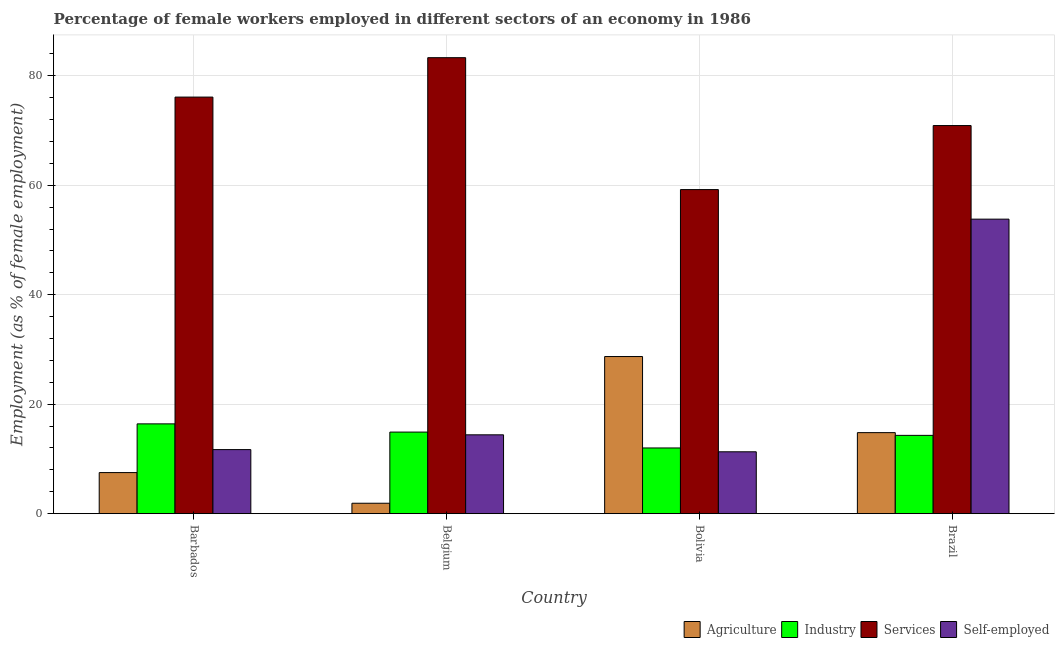Are the number of bars per tick equal to the number of legend labels?
Your answer should be compact. Yes. Are the number of bars on each tick of the X-axis equal?
Your answer should be very brief. Yes. What is the label of the 1st group of bars from the left?
Your answer should be compact. Barbados. What is the percentage of female workers in industry in Barbados?
Give a very brief answer. 16.4. Across all countries, what is the maximum percentage of self employed female workers?
Your answer should be compact. 53.8. Across all countries, what is the minimum percentage of female workers in services?
Make the answer very short. 59.2. In which country was the percentage of female workers in industry maximum?
Offer a very short reply. Barbados. What is the total percentage of female workers in services in the graph?
Keep it short and to the point. 289.5. What is the difference between the percentage of female workers in services in Bolivia and that in Brazil?
Give a very brief answer. -11.7. What is the difference between the percentage of female workers in agriculture in Bolivia and the percentage of female workers in industry in Barbados?
Provide a succinct answer. 12.3. What is the average percentage of self employed female workers per country?
Make the answer very short. 22.8. What is the difference between the percentage of self employed female workers and percentage of female workers in industry in Bolivia?
Ensure brevity in your answer.  -0.7. What is the ratio of the percentage of female workers in services in Bolivia to that in Brazil?
Your response must be concise. 0.83. Is the difference between the percentage of female workers in services in Belgium and Brazil greater than the difference between the percentage of self employed female workers in Belgium and Brazil?
Your answer should be very brief. Yes. What is the difference between the highest and the second highest percentage of female workers in industry?
Your answer should be compact. 1.5. What is the difference between the highest and the lowest percentage of female workers in agriculture?
Your answer should be very brief. 26.8. Is it the case that in every country, the sum of the percentage of female workers in services and percentage of female workers in agriculture is greater than the sum of percentage of female workers in industry and percentage of self employed female workers?
Give a very brief answer. Yes. What does the 2nd bar from the left in Brazil represents?
Provide a short and direct response. Industry. What does the 1st bar from the right in Bolivia represents?
Provide a short and direct response. Self-employed. Is it the case that in every country, the sum of the percentage of female workers in agriculture and percentage of female workers in industry is greater than the percentage of female workers in services?
Your answer should be compact. No. How many bars are there?
Provide a succinct answer. 16. What is the difference between two consecutive major ticks on the Y-axis?
Ensure brevity in your answer.  20. Are the values on the major ticks of Y-axis written in scientific E-notation?
Provide a succinct answer. No. Does the graph contain grids?
Keep it short and to the point. Yes. Where does the legend appear in the graph?
Your response must be concise. Bottom right. How many legend labels are there?
Give a very brief answer. 4. What is the title of the graph?
Your answer should be compact. Percentage of female workers employed in different sectors of an economy in 1986. What is the label or title of the Y-axis?
Offer a very short reply. Employment (as % of female employment). What is the Employment (as % of female employment) in Industry in Barbados?
Provide a short and direct response. 16.4. What is the Employment (as % of female employment) of Services in Barbados?
Your response must be concise. 76.1. What is the Employment (as % of female employment) of Self-employed in Barbados?
Your answer should be very brief. 11.7. What is the Employment (as % of female employment) in Agriculture in Belgium?
Your answer should be compact. 1.9. What is the Employment (as % of female employment) of Industry in Belgium?
Offer a terse response. 14.9. What is the Employment (as % of female employment) in Services in Belgium?
Make the answer very short. 83.3. What is the Employment (as % of female employment) in Self-employed in Belgium?
Provide a succinct answer. 14.4. What is the Employment (as % of female employment) in Agriculture in Bolivia?
Offer a terse response. 28.7. What is the Employment (as % of female employment) in Services in Bolivia?
Provide a succinct answer. 59.2. What is the Employment (as % of female employment) in Self-employed in Bolivia?
Your answer should be very brief. 11.3. What is the Employment (as % of female employment) of Agriculture in Brazil?
Your response must be concise. 14.8. What is the Employment (as % of female employment) in Industry in Brazil?
Your answer should be compact. 14.3. What is the Employment (as % of female employment) of Services in Brazil?
Provide a short and direct response. 70.9. What is the Employment (as % of female employment) of Self-employed in Brazil?
Give a very brief answer. 53.8. Across all countries, what is the maximum Employment (as % of female employment) of Agriculture?
Ensure brevity in your answer.  28.7. Across all countries, what is the maximum Employment (as % of female employment) of Industry?
Offer a very short reply. 16.4. Across all countries, what is the maximum Employment (as % of female employment) of Services?
Offer a very short reply. 83.3. Across all countries, what is the maximum Employment (as % of female employment) in Self-employed?
Your response must be concise. 53.8. Across all countries, what is the minimum Employment (as % of female employment) in Agriculture?
Make the answer very short. 1.9. Across all countries, what is the minimum Employment (as % of female employment) in Industry?
Your answer should be compact. 12. Across all countries, what is the minimum Employment (as % of female employment) of Services?
Offer a terse response. 59.2. Across all countries, what is the minimum Employment (as % of female employment) of Self-employed?
Your answer should be very brief. 11.3. What is the total Employment (as % of female employment) of Agriculture in the graph?
Provide a succinct answer. 52.9. What is the total Employment (as % of female employment) of Industry in the graph?
Make the answer very short. 57.6. What is the total Employment (as % of female employment) in Services in the graph?
Your answer should be compact. 289.5. What is the total Employment (as % of female employment) of Self-employed in the graph?
Ensure brevity in your answer.  91.2. What is the difference between the Employment (as % of female employment) in Industry in Barbados and that in Belgium?
Offer a very short reply. 1.5. What is the difference between the Employment (as % of female employment) in Services in Barbados and that in Belgium?
Your answer should be compact. -7.2. What is the difference between the Employment (as % of female employment) of Self-employed in Barbados and that in Belgium?
Provide a short and direct response. -2.7. What is the difference between the Employment (as % of female employment) in Agriculture in Barbados and that in Bolivia?
Offer a terse response. -21.2. What is the difference between the Employment (as % of female employment) of Self-employed in Barbados and that in Bolivia?
Your answer should be very brief. 0.4. What is the difference between the Employment (as % of female employment) of Agriculture in Barbados and that in Brazil?
Provide a succinct answer. -7.3. What is the difference between the Employment (as % of female employment) of Industry in Barbados and that in Brazil?
Offer a very short reply. 2.1. What is the difference between the Employment (as % of female employment) in Services in Barbados and that in Brazil?
Make the answer very short. 5.2. What is the difference between the Employment (as % of female employment) in Self-employed in Barbados and that in Brazil?
Your answer should be compact. -42.1. What is the difference between the Employment (as % of female employment) of Agriculture in Belgium and that in Bolivia?
Keep it short and to the point. -26.8. What is the difference between the Employment (as % of female employment) in Services in Belgium and that in Bolivia?
Your answer should be compact. 24.1. What is the difference between the Employment (as % of female employment) of Self-employed in Belgium and that in Bolivia?
Ensure brevity in your answer.  3.1. What is the difference between the Employment (as % of female employment) of Agriculture in Belgium and that in Brazil?
Ensure brevity in your answer.  -12.9. What is the difference between the Employment (as % of female employment) in Industry in Belgium and that in Brazil?
Offer a very short reply. 0.6. What is the difference between the Employment (as % of female employment) in Self-employed in Belgium and that in Brazil?
Your answer should be very brief. -39.4. What is the difference between the Employment (as % of female employment) in Agriculture in Bolivia and that in Brazil?
Your answer should be compact. 13.9. What is the difference between the Employment (as % of female employment) of Services in Bolivia and that in Brazil?
Ensure brevity in your answer.  -11.7. What is the difference between the Employment (as % of female employment) of Self-employed in Bolivia and that in Brazil?
Your answer should be very brief. -42.5. What is the difference between the Employment (as % of female employment) in Agriculture in Barbados and the Employment (as % of female employment) in Industry in Belgium?
Your answer should be compact. -7.4. What is the difference between the Employment (as % of female employment) in Agriculture in Barbados and the Employment (as % of female employment) in Services in Belgium?
Keep it short and to the point. -75.8. What is the difference between the Employment (as % of female employment) in Industry in Barbados and the Employment (as % of female employment) in Services in Belgium?
Provide a short and direct response. -66.9. What is the difference between the Employment (as % of female employment) in Services in Barbados and the Employment (as % of female employment) in Self-employed in Belgium?
Offer a terse response. 61.7. What is the difference between the Employment (as % of female employment) of Agriculture in Barbados and the Employment (as % of female employment) of Services in Bolivia?
Offer a very short reply. -51.7. What is the difference between the Employment (as % of female employment) in Agriculture in Barbados and the Employment (as % of female employment) in Self-employed in Bolivia?
Offer a terse response. -3.8. What is the difference between the Employment (as % of female employment) of Industry in Barbados and the Employment (as % of female employment) of Services in Bolivia?
Make the answer very short. -42.8. What is the difference between the Employment (as % of female employment) in Industry in Barbados and the Employment (as % of female employment) in Self-employed in Bolivia?
Your answer should be very brief. 5.1. What is the difference between the Employment (as % of female employment) of Services in Barbados and the Employment (as % of female employment) of Self-employed in Bolivia?
Offer a very short reply. 64.8. What is the difference between the Employment (as % of female employment) in Agriculture in Barbados and the Employment (as % of female employment) in Services in Brazil?
Offer a very short reply. -63.4. What is the difference between the Employment (as % of female employment) of Agriculture in Barbados and the Employment (as % of female employment) of Self-employed in Brazil?
Your response must be concise. -46.3. What is the difference between the Employment (as % of female employment) in Industry in Barbados and the Employment (as % of female employment) in Services in Brazil?
Provide a short and direct response. -54.5. What is the difference between the Employment (as % of female employment) in Industry in Barbados and the Employment (as % of female employment) in Self-employed in Brazil?
Provide a short and direct response. -37.4. What is the difference between the Employment (as % of female employment) of Services in Barbados and the Employment (as % of female employment) of Self-employed in Brazil?
Provide a short and direct response. 22.3. What is the difference between the Employment (as % of female employment) of Agriculture in Belgium and the Employment (as % of female employment) of Services in Bolivia?
Provide a short and direct response. -57.3. What is the difference between the Employment (as % of female employment) in Agriculture in Belgium and the Employment (as % of female employment) in Self-employed in Bolivia?
Provide a succinct answer. -9.4. What is the difference between the Employment (as % of female employment) in Industry in Belgium and the Employment (as % of female employment) in Services in Bolivia?
Provide a succinct answer. -44.3. What is the difference between the Employment (as % of female employment) of Agriculture in Belgium and the Employment (as % of female employment) of Services in Brazil?
Your answer should be compact. -69. What is the difference between the Employment (as % of female employment) of Agriculture in Belgium and the Employment (as % of female employment) of Self-employed in Brazil?
Your answer should be compact. -51.9. What is the difference between the Employment (as % of female employment) in Industry in Belgium and the Employment (as % of female employment) in Services in Brazil?
Make the answer very short. -56. What is the difference between the Employment (as % of female employment) in Industry in Belgium and the Employment (as % of female employment) in Self-employed in Brazil?
Offer a terse response. -38.9. What is the difference between the Employment (as % of female employment) of Services in Belgium and the Employment (as % of female employment) of Self-employed in Brazil?
Offer a very short reply. 29.5. What is the difference between the Employment (as % of female employment) of Agriculture in Bolivia and the Employment (as % of female employment) of Industry in Brazil?
Give a very brief answer. 14.4. What is the difference between the Employment (as % of female employment) of Agriculture in Bolivia and the Employment (as % of female employment) of Services in Brazil?
Keep it short and to the point. -42.2. What is the difference between the Employment (as % of female employment) of Agriculture in Bolivia and the Employment (as % of female employment) of Self-employed in Brazil?
Ensure brevity in your answer.  -25.1. What is the difference between the Employment (as % of female employment) of Industry in Bolivia and the Employment (as % of female employment) of Services in Brazil?
Your answer should be compact. -58.9. What is the difference between the Employment (as % of female employment) of Industry in Bolivia and the Employment (as % of female employment) of Self-employed in Brazil?
Your response must be concise. -41.8. What is the average Employment (as % of female employment) in Agriculture per country?
Give a very brief answer. 13.22. What is the average Employment (as % of female employment) in Industry per country?
Your answer should be compact. 14.4. What is the average Employment (as % of female employment) in Services per country?
Give a very brief answer. 72.38. What is the average Employment (as % of female employment) of Self-employed per country?
Your answer should be very brief. 22.8. What is the difference between the Employment (as % of female employment) in Agriculture and Employment (as % of female employment) in Services in Barbados?
Keep it short and to the point. -68.6. What is the difference between the Employment (as % of female employment) in Agriculture and Employment (as % of female employment) in Self-employed in Barbados?
Provide a succinct answer. -4.2. What is the difference between the Employment (as % of female employment) of Industry and Employment (as % of female employment) of Services in Barbados?
Make the answer very short. -59.7. What is the difference between the Employment (as % of female employment) in Services and Employment (as % of female employment) in Self-employed in Barbados?
Give a very brief answer. 64.4. What is the difference between the Employment (as % of female employment) of Agriculture and Employment (as % of female employment) of Industry in Belgium?
Offer a terse response. -13. What is the difference between the Employment (as % of female employment) in Agriculture and Employment (as % of female employment) in Services in Belgium?
Give a very brief answer. -81.4. What is the difference between the Employment (as % of female employment) in Agriculture and Employment (as % of female employment) in Self-employed in Belgium?
Your response must be concise. -12.5. What is the difference between the Employment (as % of female employment) of Industry and Employment (as % of female employment) of Services in Belgium?
Provide a short and direct response. -68.4. What is the difference between the Employment (as % of female employment) in Industry and Employment (as % of female employment) in Self-employed in Belgium?
Your answer should be compact. 0.5. What is the difference between the Employment (as % of female employment) in Services and Employment (as % of female employment) in Self-employed in Belgium?
Offer a very short reply. 68.9. What is the difference between the Employment (as % of female employment) of Agriculture and Employment (as % of female employment) of Services in Bolivia?
Your response must be concise. -30.5. What is the difference between the Employment (as % of female employment) in Industry and Employment (as % of female employment) in Services in Bolivia?
Provide a succinct answer. -47.2. What is the difference between the Employment (as % of female employment) in Industry and Employment (as % of female employment) in Self-employed in Bolivia?
Make the answer very short. 0.7. What is the difference between the Employment (as % of female employment) in Services and Employment (as % of female employment) in Self-employed in Bolivia?
Make the answer very short. 47.9. What is the difference between the Employment (as % of female employment) in Agriculture and Employment (as % of female employment) in Services in Brazil?
Your response must be concise. -56.1. What is the difference between the Employment (as % of female employment) of Agriculture and Employment (as % of female employment) of Self-employed in Brazil?
Give a very brief answer. -39. What is the difference between the Employment (as % of female employment) in Industry and Employment (as % of female employment) in Services in Brazil?
Give a very brief answer. -56.6. What is the difference between the Employment (as % of female employment) of Industry and Employment (as % of female employment) of Self-employed in Brazil?
Ensure brevity in your answer.  -39.5. What is the difference between the Employment (as % of female employment) in Services and Employment (as % of female employment) in Self-employed in Brazil?
Your response must be concise. 17.1. What is the ratio of the Employment (as % of female employment) in Agriculture in Barbados to that in Belgium?
Your answer should be compact. 3.95. What is the ratio of the Employment (as % of female employment) of Industry in Barbados to that in Belgium?
Offer a terse response. 1.1. What is the ratio of the Employment (as % of female employment) of Services in Barbados to that in Belgium?
Give a very brief answer. 0.91. What is the ratio of the Employment (as % of female employment) of Self-employed in Barbados to that in Belgium?
Ensure brevity in your answer.  0.81. What is the ratio of the Employment (as % of female employment) in Agriculture in Barbados to that in Bolivia?
Offer a terse response. 0.26. What is the ratio of the Employment (as % of female employment) in Industry in Barbados to that in Bolivia?
Keep it short and to the point. 1.37. What is the ratio of the Employment (as % of female employment) in Services in Barbados to that in Bolivia?
Give a very brief answer. 1.29. What is the ratio of the Employment (as % of female employment) of Self-employed in Barbados to that in Bolivia?
Provide a short and direct response. 1.04. What is the ratio of the Employment (as % of female employment) of Agriculture in Barbados to that in Brazil?
Offer a very short reply. 0.51. What is the ratio of the Employment (as % of female employment) of Industry in Barbados to that in Brazil?
Offer a very short reply. 1.15. What is the ratio of the Employment (as % of female employment) in Services in Barbados to that in Brazil?
Keep it short and to the point. 1.07. What is the ratio of the Employment (as % of female employment) in Self-employed in Barbados to that in Brazil?
Provide a succinct answer. 0.22. What is the ratio of the Employment (as % of female employment) in Agriculture in Belgium to that in Bolivia?
Offer a terse response. 0.07. What is the ratio of the Employment (as % of female employment) in Industry in Belgium to that in Bolivia?
Make the answer very short. 1.24. What is the ratio of the Employment (as % of female employment) of Services in Belgium to that in Bolivia?
Keep it short and to the point. 1.41. What is the ratio of the Employment (as % of female employment) in Self-employed in Belgium to that in Bolivia?
Provide a short and direct response. 1.27. What is the ratio of the Employment (as % of female employment) in Agriculture in Belgium to that in Brazil?
Your response must be concise. 0.13. What is the ratio of the Employment (as % of female employment) in Industry in Belgium to that in Brazil?
Your answer should be compact. 1.04. What is the ratio of the Employment (as % of female employment) of Services in Belgium to that in Brazil?
Provide a short and direct response. 1.17. What is the ratio of the Employment (as % of female employment) in Self-employed in Belgium to that in Brazil?
Ensure brevity in your answer.  0.27. What is the ratio of the Employment (as % of female employment) of Agriculture in Bolivia to that in Brazil?
Give a very brief answer. 1.94. What is the ratio of the Employment (as % of female employment) of Industry in Bolivia to that in Brazil?
Make the answer very short. 0.84. What is the ratio of the Employment (as % of female employment) of Services in Bolivia to that in Brazil?
Ensure brevity in your answer.  0.83. What is the ratio of the Employment (as % of female employment) of Self-employed in Bolivia to that in Brazil?
Offer a very short reply. 0.21. What is the difference between the highest and the second highest Employment (as % of female employment) of Agriculture?
Ensure brevity in your answer.  13.9. What is the difference between the highest and the second highest Employment (as % of female employment) in Industry?
Ensure brevity in your answer.  1.5. What is the difference between the highest and the second highest Employment (as % of female employment) of Services?
Provide a short and direct response. 7.2. What is the difference between the highest and the second highest Employment (as % of female employment) in Self-employed?
Offer a very short reply. 39.4. What is the difference between the highest and the lowest Employment (as % of female employment) of Agriculture?
Provide a succinct answer. 26.8. What is the difference between the highest and the lowest Employment (as % of female employment) of Services?
Your answer should be very brief. 24.1. What is the difference between the highest and the lowest Employment (as % of female employment) in Self-employed?
Your answer should be compact. 42.5. 